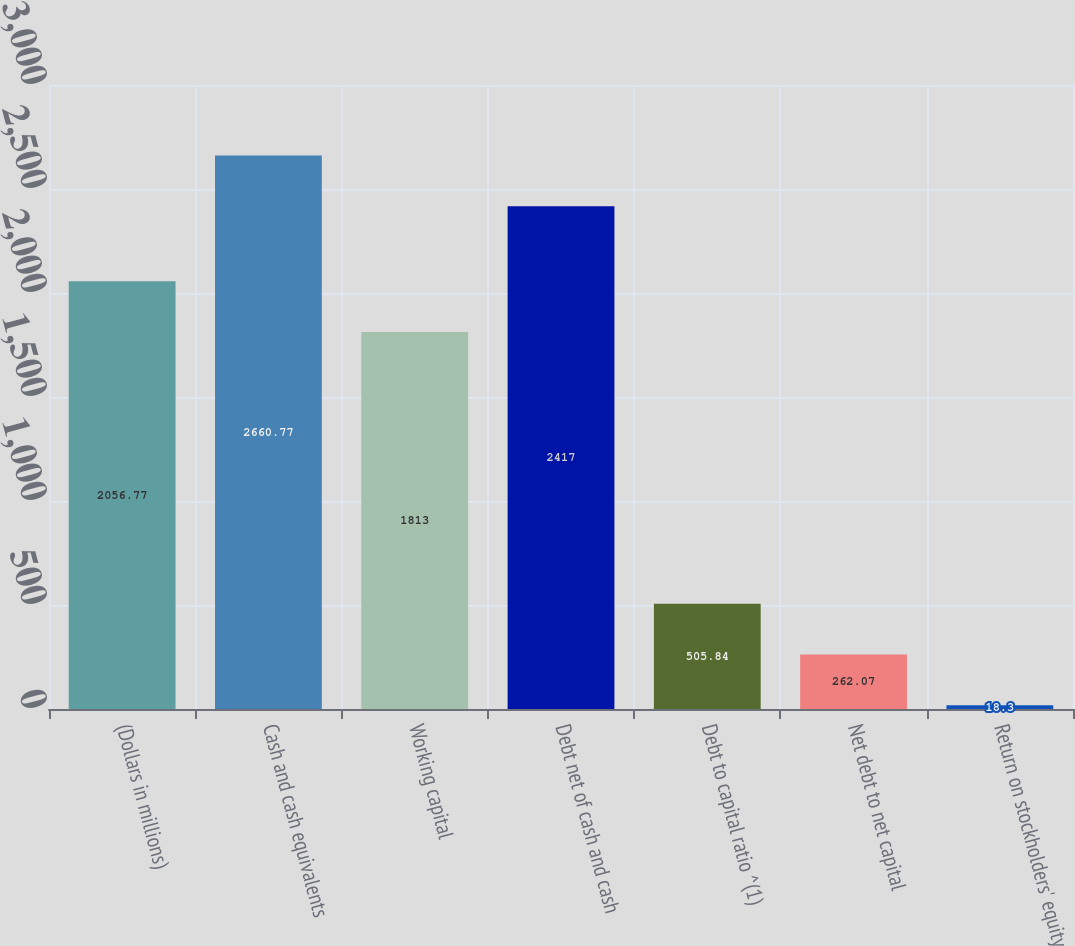<chart> <loc_0><loc_0><loc_500><loc_500><bar_chart><fcel>(Dollars in millions)<fcel>Cash and cash equivalents<fcel>Working capital<fcel>Debt net of cash and cash<fcel>Debt to capital ratio ^(1)<fcel>Net debt to net capital<fcel>Return on stockholders' equity<nl><fcel>2056.77<fcel>2660.77<fcel>1813<fcel>2417<fcel>505.84<fcel>262.07<fcel>18.3<nl></chart> 